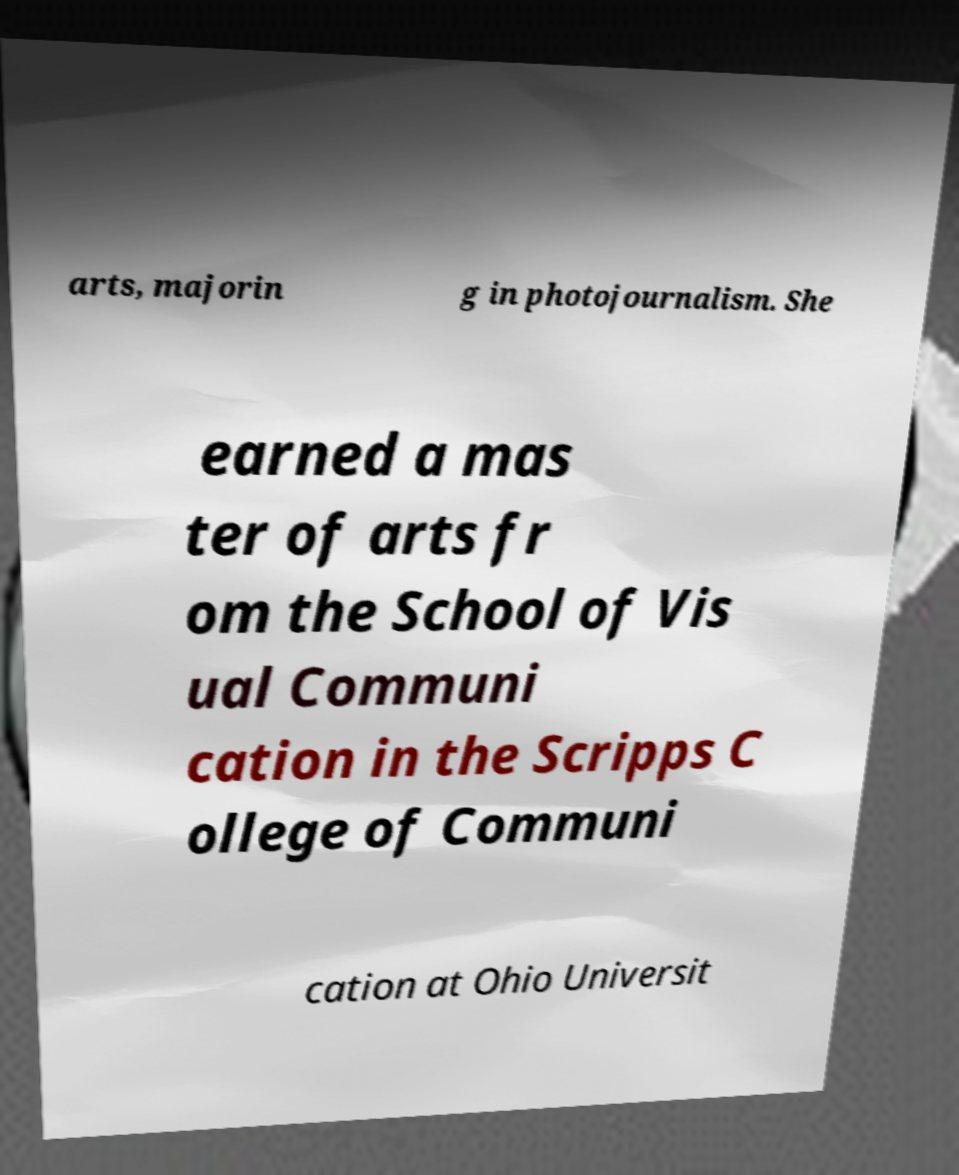Please identify and transcribe the text found in this image. arts, majorin g in photojournalism. She earned a mas ter of arts fr om the School of Vis ual Communi cation in the Scripps C ollege of Communi cation at Ohio Universit 